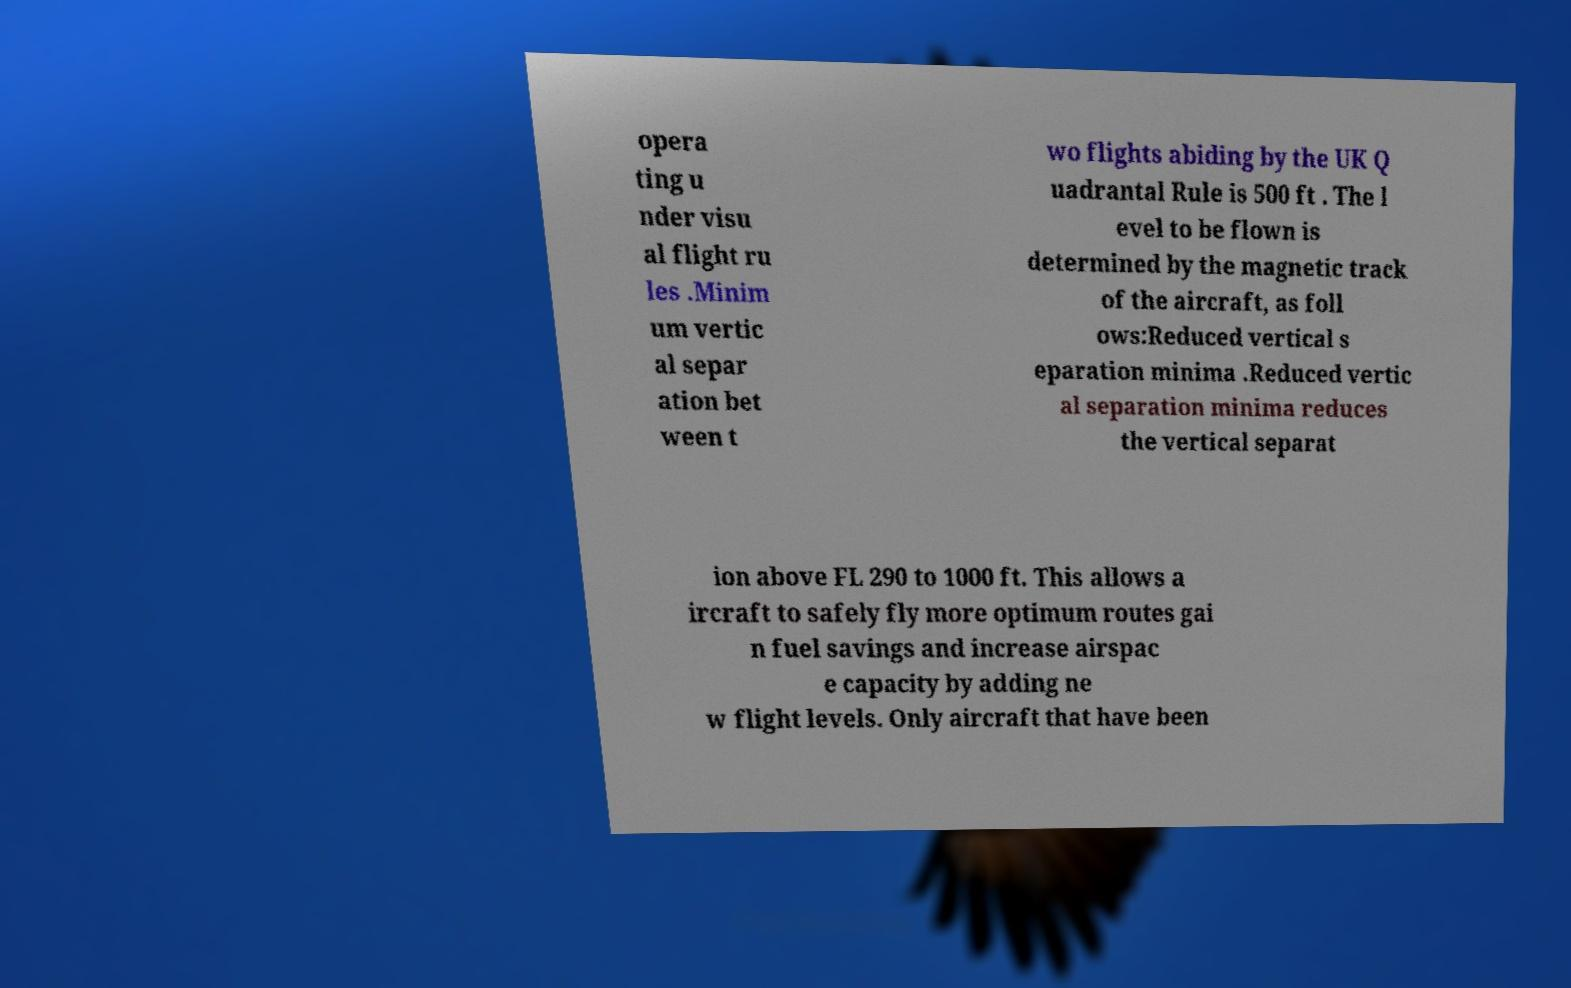Please read and relay the text visible in this image. What does it say? opera ting u nder visu al flight ru les .Minim um vertic al separ ation bet ween t wo flights abiding by the UK Q uadrantal Rule is 500 ft . The l evel to be flown is determined by the magnetic track of the aircraft, as foll ows:Reduced vertical s eparation minima .Reduced vertic al separation minima reduces the vertical separat ion above FL 290 to 1000 ft. This allows a ircraft to safely fly more optimum routes gai n fuel savings and increase airspac e capacity by adding ne w flight levels. Only aircraft that have been 